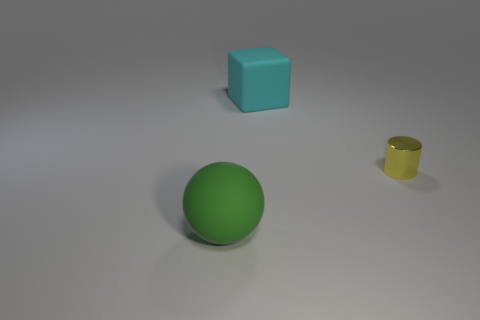What might be the function of the yellow object in the image? The yellow object in the image looks like a cup, which is commonly used for holding liquids for drinking. Its upright position suggests it's ready to be used.  Are there any other objects in the image that have a clear function? Aside from the yellow cup, the function of the other objects isn't as clear from the image alone. The sphere could be a toy or used for sports, and the cube might be a toy, a decorative object, or even a learning tool for children, depending on its exact material and context. 